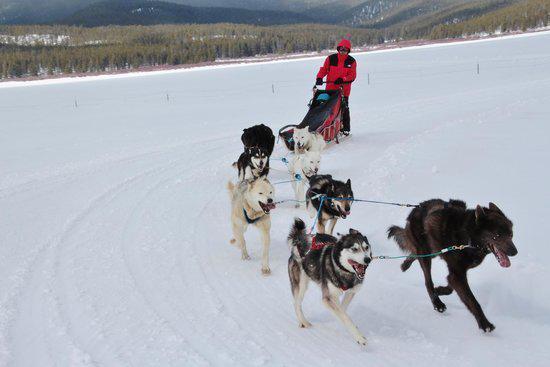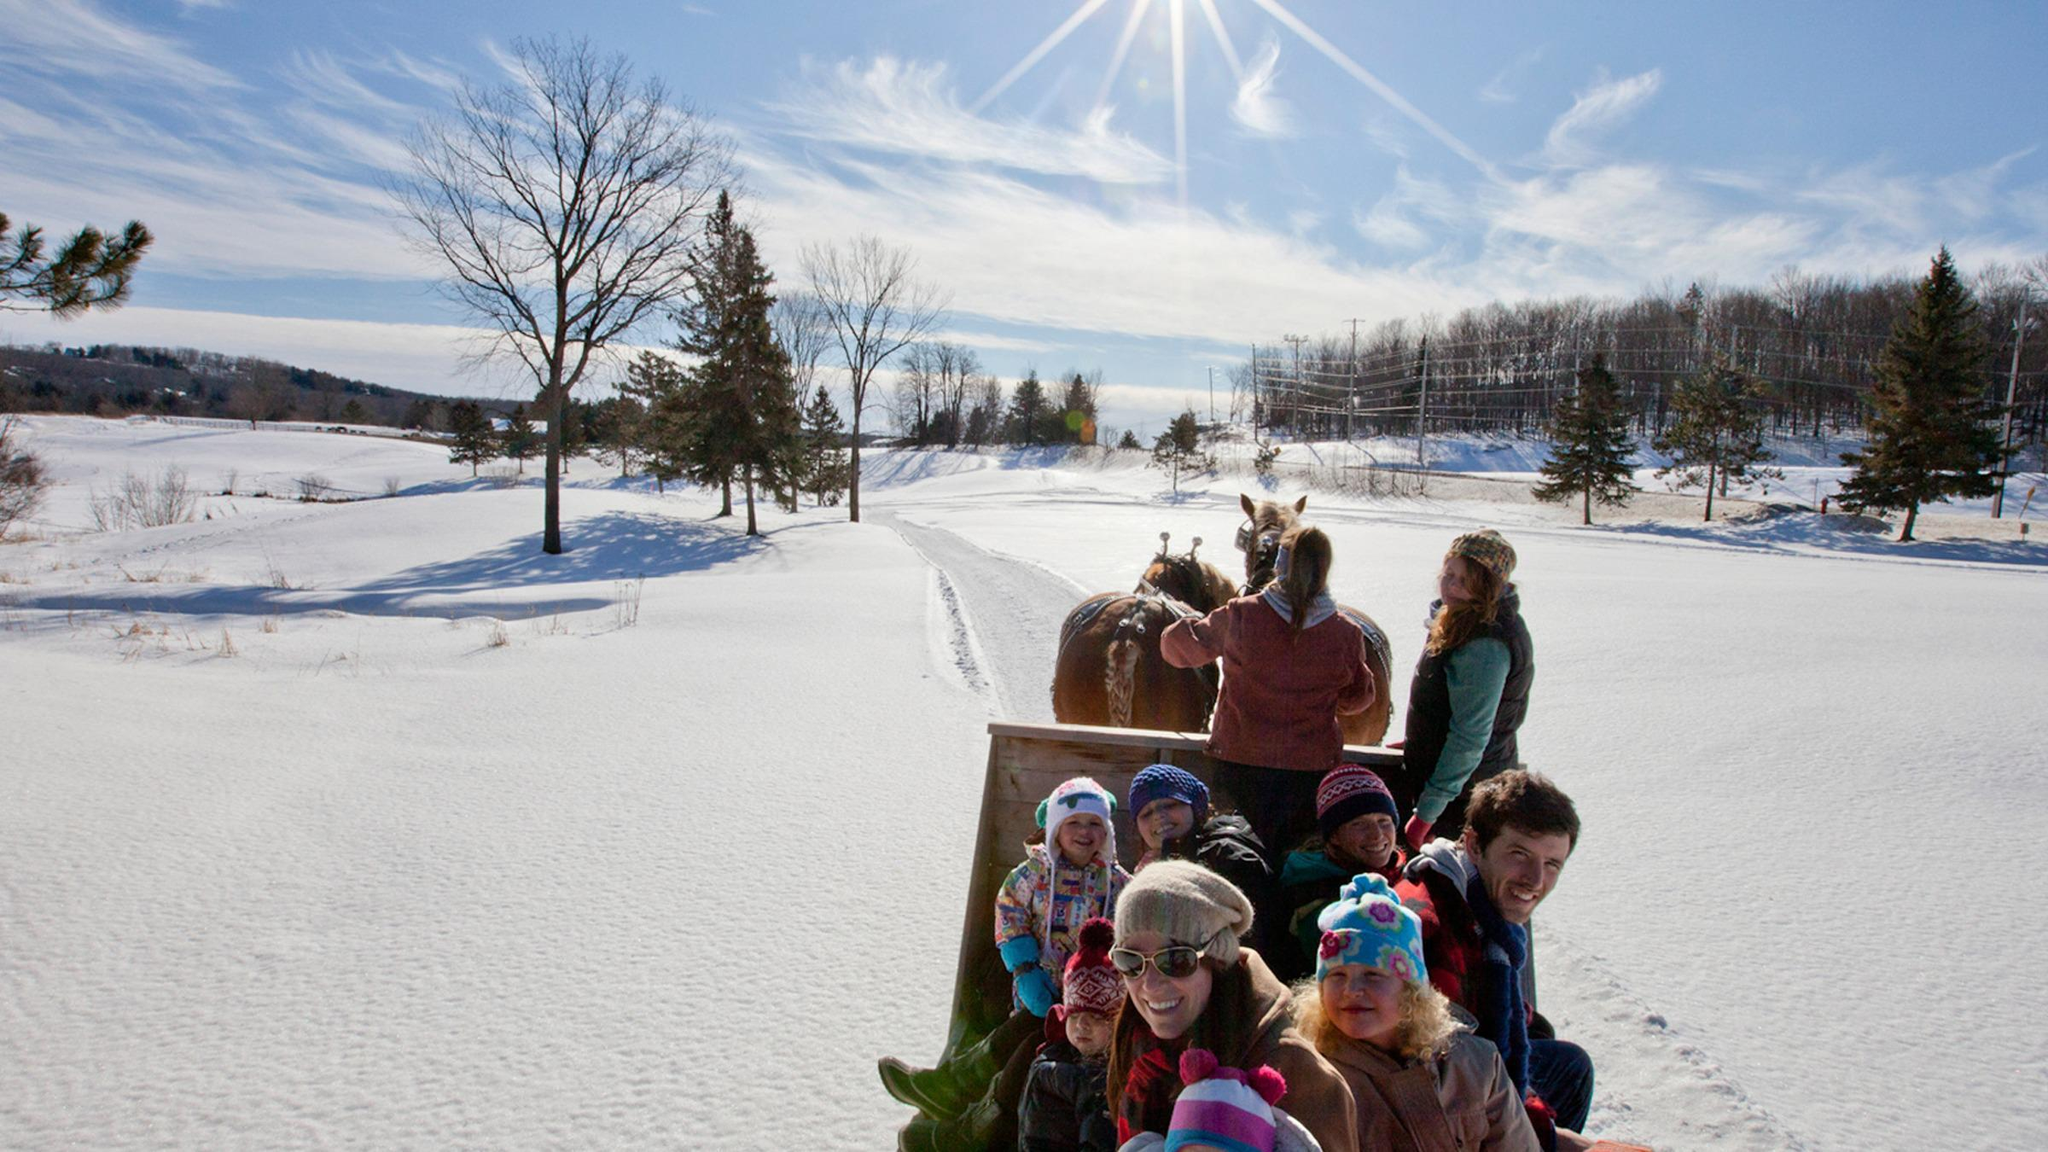The first image is the image on the left, the second image is the image on the right. Evaluate the accuracy of this statement regarding the images: "Some dogs are resting.". Is it true? Answer yes or no. No. The first image is the image on the left, the second image is the image on the right. Evaluate the accuracy of this statement regarding the images: "In at least one image there is a person in blue in the sled and a person in red behind the sled.". Is it true? Answer yes or no. Yes. 